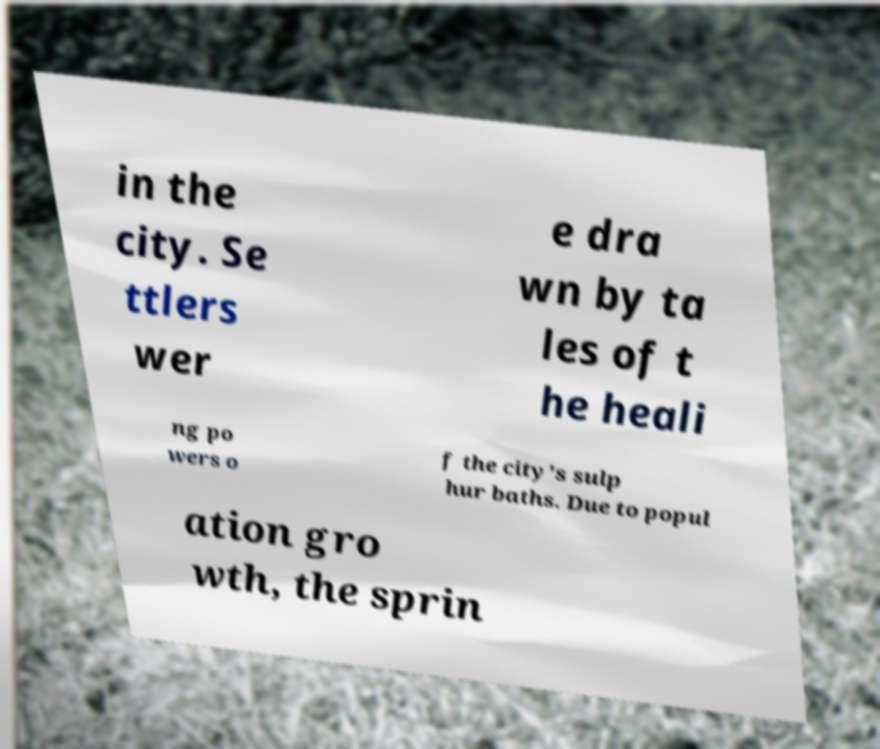I need the written content from this picture converted into text. Can you do that? in the city. Se ttlers wer e dra wn by ta les of t he heali ng po wers o f the city's sulp hur baths. Due to popul ation gro wth, the sprin 